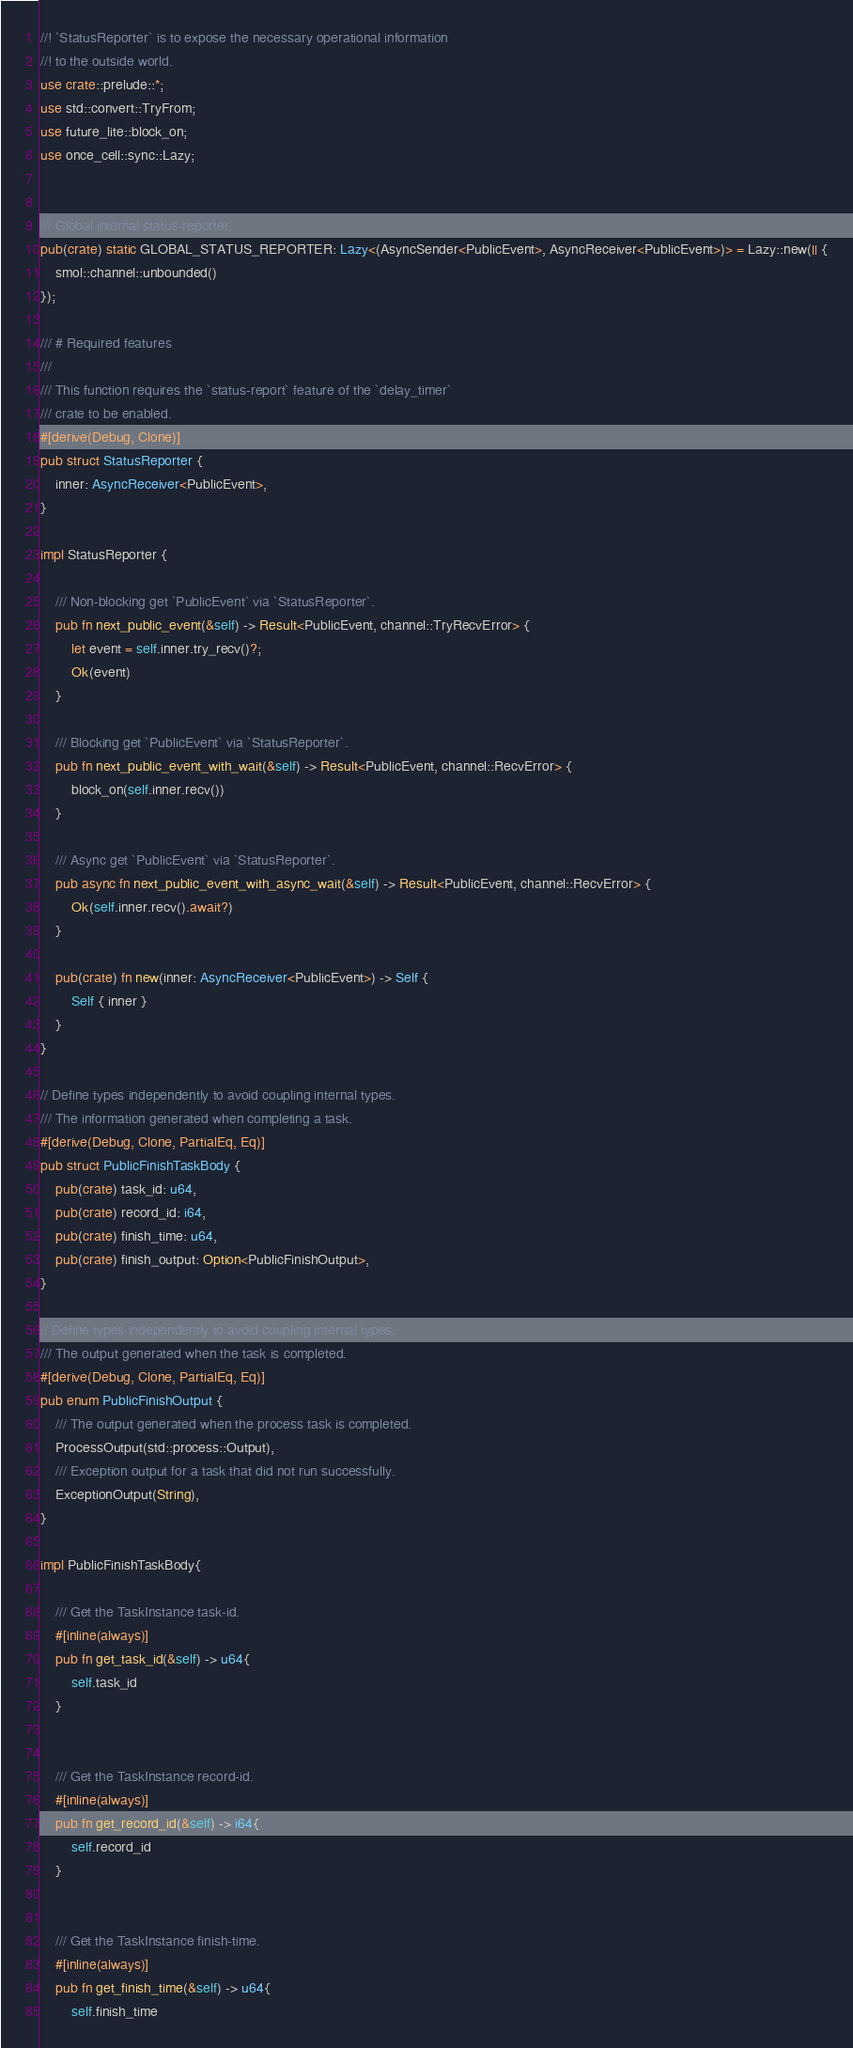<code> <loc_0><loc_0><loc_500><loc_500><_Rust_>//! `StatusReporter` is to expose the necessary operational information
//! to the outside world.
use crate::prelude::*;
use std::convert::TryFrom;
use future_lite::block_on;
use once_cell::sync::Lazy;


/// Global internal status-reporter.
pub(crate) static GLOBAL_STATUS_REPORTER: Lazy<(AsyncSender<PublicEvent>, AsyncReceiver<PublicEvent>)> = Lazy::new(|| {
    smol::channel::unbounded()
});

/// # Required features
///
/// This function requires the `status-report` feature of the `delay_timer`
/// crate to be enabled.
#[derive(Debug, Clone)]
pub struct StatusReporter {
    inner: AsyncReceiver<PublicEvent>,
}

impl StatusReporter {

    /// Non-blocking get `PublicEvent` via `StatusReporter`.
    pub fn next_public_event(&self) -> Result<PublicEvent, channel::TryRecvError> {
        let event = self.inner.try_recv()?;
        Ok(event)
    }

    /// Blocking get `PublicEvent` via `StatusReporter`.
    pub fn next_public_event_with_wait(&self) -> Result<PublicEvent, channel::RecvError> {
        block_on(self.inner.recv())
    }

    /// Async get `PublicEvent` via `StatusReporter`.
    pub async fn next_public_event_with_async_wait(&self) -> Result<PublicEvent, channel::RecvError> {
        Ok(self.inner.recv().await?)
    }

    pub(crate) fn new(inner: AsyncReceiver<PublicEvent>) -> Self {
        Self { inner }
    }
}

// Define types independently to avoid coupling internal types.
/// The information generated when completing a task.
#[derive(Debug, Clone, PartialEq, Eq)]
pub struct PublicFinishTaskBody {
    pub(crate) task_id: u64,
    pub(crate) record_id: i64,
    pub(crate) finish_time: u64,
    pub(crate) finish_output: Option<PublicFinishOutput>,
}

// Define types independently to avoid coupling internal types.
/// The output generated when the task is completed.
#[derive(Debug, Clone, PartialEq, Eq)]
pub enum PublicFinishOutput {
    /// The output generated when the process task is completed.
    ProcessOutput(std::process::Output),
    /// Exception output for a task that did not run successfully.
    ExceptionOutput(String),
}

impl PublicFinishTaskBody{

    /// Get the TaskInstance task-id.
    #[inline(always)]
    pub fn get_task_id(&self) -> u64{
        self.task_id
    }


    /// Get the TaskInstance record-id.
    #[inline(always)]
    pub fn get_record_id(&self) -> i64{
        self.record_id
    }


    /// Get the TaskInstance finish-time.
    #[inline(always)]
    pub fn get_finish_time(&self) -> u64{
        self.finish_time</code> 